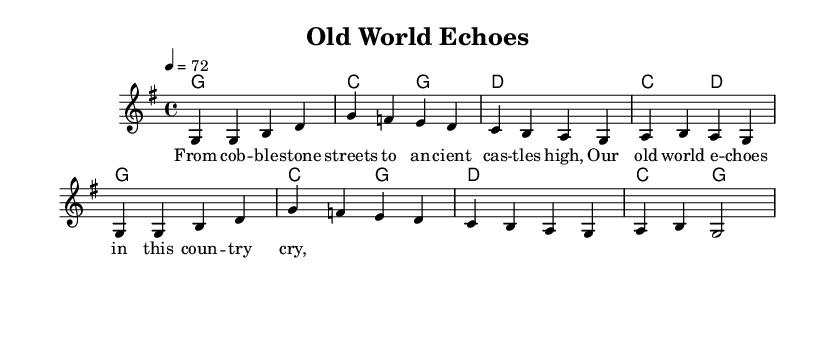What is the key signature of this music? The key signature is G major, indicated by one sharp (F#) at the beginning of the staff. This can be concluded by examining the key signature section which is located right after the clef sign and before the time signature.
Answer: G major What is the time signature of this music? The time signature is 4/4, which is commonly found in many musical styles. It is located directly after the key signature at the beginning of the staff and indicates that there are four beats in each measure.
Answer: 4/4 What is the tempo marking of the piece? The tempo marking is 4 = 72, which indicates the number of beats per minute. This means that each quarter note is to be played at a speed of 72 beats per minute. This information is found right after the time signature within the score.
Answer: 72 How many measures are there in the score? There are 8 measures in the score. This can be determined by counting the vertical lines that divide the staff into separate segments, each representing a measure, throughout the entire composition.
Answer: 8 What is the title of this piece? The title of the piece is "Old World Echoes", which is specified in the header section at the top of the score. It is the formal name assigned to this musical work, providing insight into its thematic content.
Answer: Old World Echoes What do the lyrics reflect about European culture? The lyrics reflect the connection to historical architecture and landscapes, such as "cobblestone streets" and "ancient castles", indicating a nostalgic appreciation for European traditions. These themes can be inferred from the lyrical content presented in the score, which resonates with imagery tied to European heritage.
Answer: Historical architecture 